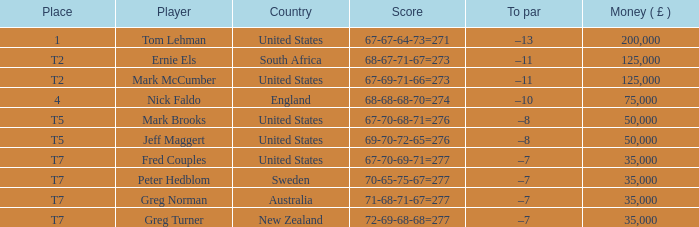What is the highest Money ( £ ), when Player is "Peter Hedblom"? 35000.0. 